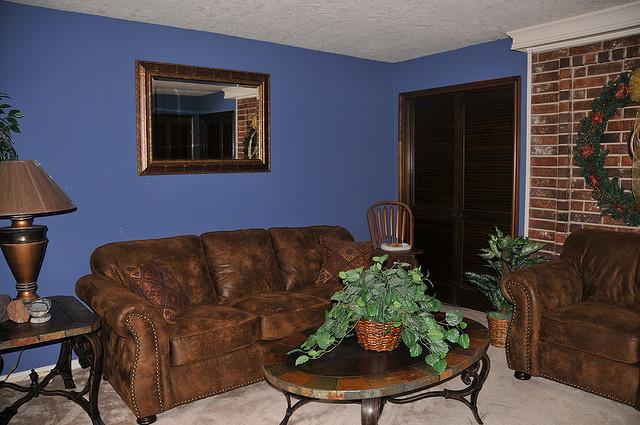According to the reflection, what's behind the photographer?
Answer briefly. Window. What kind of portrait hands on the wall?
Write a very short answer. Mirror. How many plants are there?
Answer briefly. 2. What is in the corner?
Answer briefly. Chair. 